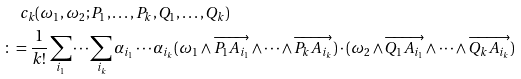Convert formula to latex. <formula><loc_0><loc_0><loc_500><loc_500>& \quad c _ { k } ( \omega _ { 1 } , \omega _ { 2 } ; P _ { 1 } , \dots , P _ { k } , Q _ { 1 } , \dots , Q _ { k } ) \\ & \colon = \frac { 1 } { k ! } \sum _ { i _ { 1 } } \cdots \sum _ { i _ { k } } \alpha _ { i _ { 1 } } \cdots \alpha _ { i _ { k } } ( \omega _ { 1 } \wedge \overrightarrow { P _ { 1 } A _ { i _ { 1 } } } \wedge \cdots \wedge \overrightarrow { P _ { k } A _ { i _ { k } } } ) \cdot ( \omega _ { 2 } \wedge \overrightarrow { Q _ { 1 } A _ { i _ { 1 } } } \wedge \cdots \wedge \overrightarrow { Q _ { k } A _ { i _ { k } } } )</formula> 